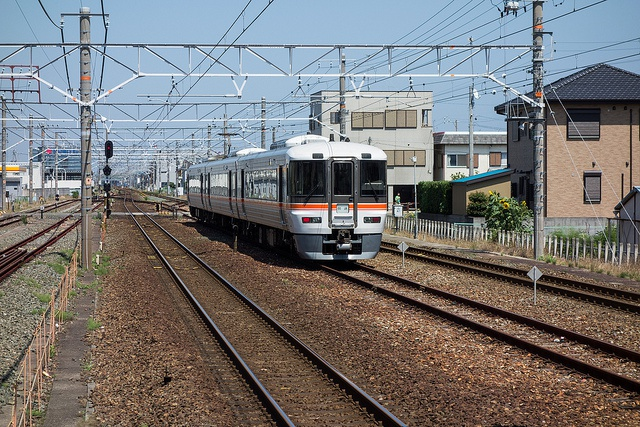Describe the objects in this image and their specific colors. I can see train in darkgray, black, gray, and lightgray tones, traffic light in darkgray, black, and gray tones, and people in darkgray, black, teal, gray, and beige tones in this image. 